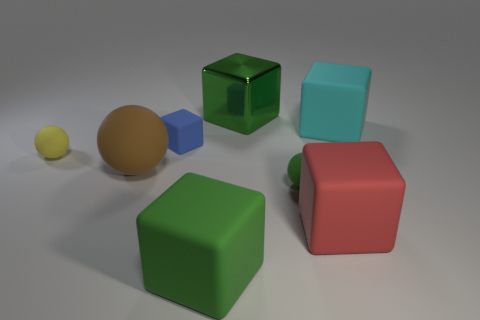The tiny object that is both right of the yellow rubber object and behind the large rubber ball is what color?
Your response must be concise. Blue. What number of big red rubber cubes are in front of the yellow matte sphere?
Offer a very short reply. 1. What number of objects are blue things or matte cubes that are behind the tiny blue matte cube?
Ensure brevity in your answer.  2. Are there any green balls to the left of the small rubber ball that is behind the large rubber ball?
Your answer should be compact. No. The large metallic cube that is to the right of the tiny yellow matte sphere is what color?
Your response must be concise. Green. Is the number of green rubber spheres that are to the right of the tiny blue cube the same as the number of large matte things?
Your answer should be compact. No. There is a rubber object that is both on the right side of the brown rubber thing and to the left of the large green rubber object; what is its shape?
Ensure brevity in your answer.  Cube. What color is the metallic thing that is the same shape as the large cyan rubber thing?
Keep it short and to the point. Green. Are there any other things that have the same color as the large metallic object?
Your response must be concise. Yes. There is a big green thing behind the ball behind the large matte object that is on the left side of the tiny matte cube; what is its shape?
Give a very brief answer. Cube. 